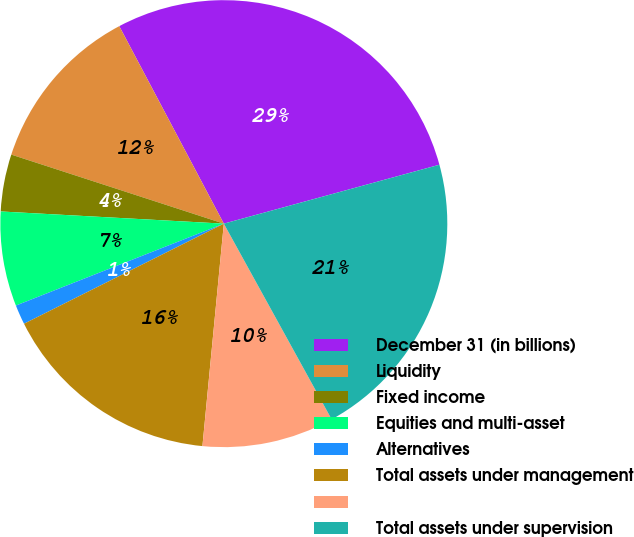Convert chart to OTSL. <chart><loc_0><loc_0><loc_500><loc_500><pie_chart><fcel>December 31 (in billions)<fcel>Liquidity<fcel>Fixed income<fcel>Equities and multi-asset<fcel>Alternatives<fcel>Total assets under management<fcel>Unnamed: 6<fcel>Total assets under supervision<nl><fcel>28.5%<fcel>12.25%<fcel>4.13%<fcel>6.84%<fcel>1.42%<fcel>16.08%<fcel>9.54%<fcel>21.23%<nl></chart> 